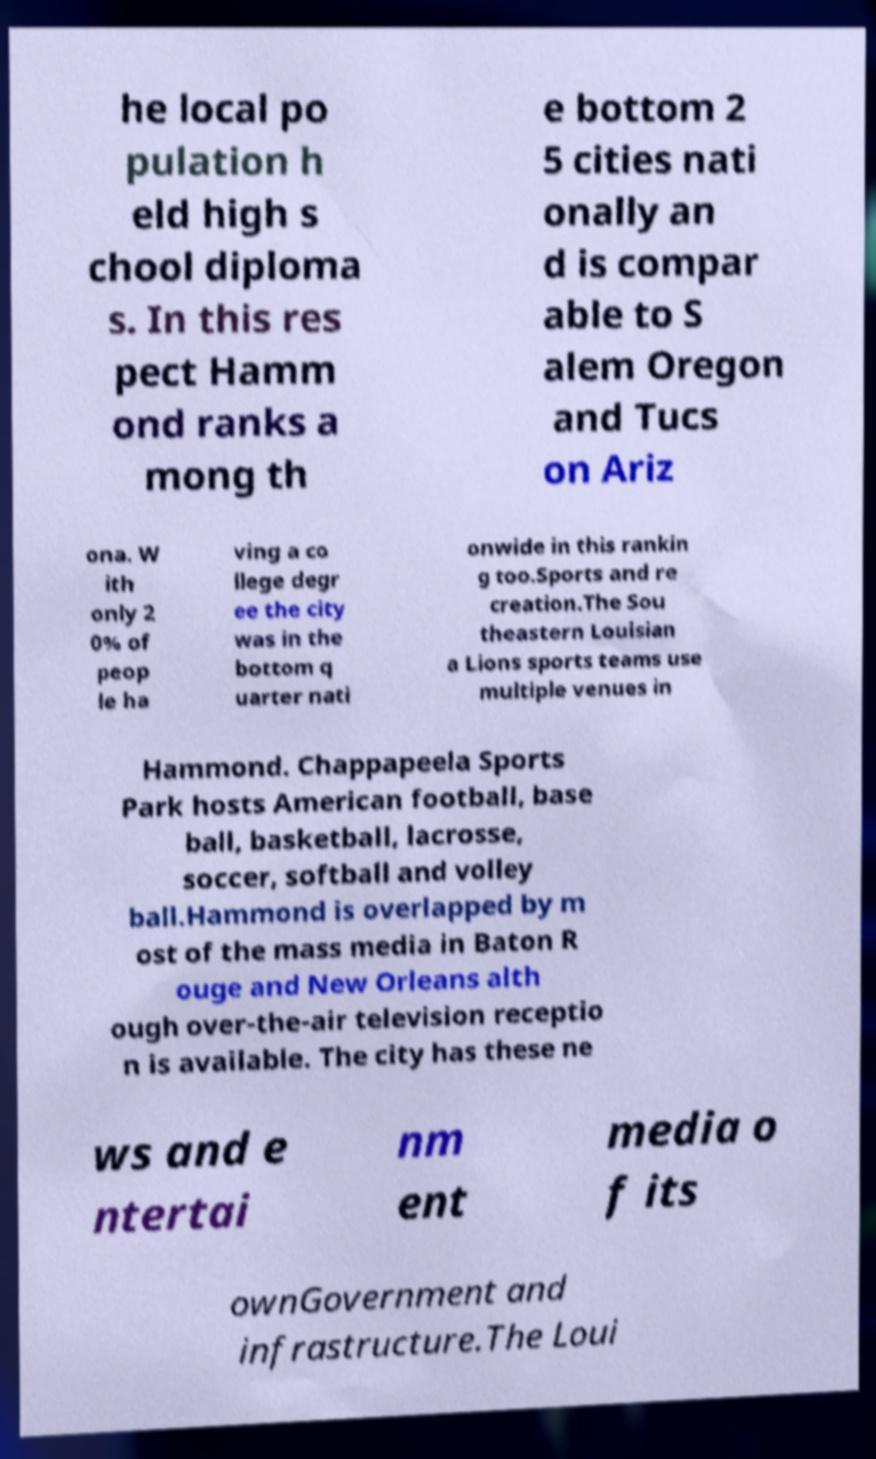Please identify and transcribe the text found in this image. he local po pulation h eld high s chool diploma s. In this res pect Hamm ond ranks a mong th e bottom 2 5 cities nati onally an d is compar able to S alem Oregon and Tucs on Ariz ona. W ith only 2 0% of peop le ha ving a co llege degr ee the city was in the bottom q uarter nati onwide in this rankin g too.Sports and re creation.The Sou theastern Louisian a Lions sports teams use multiple venues in Hammond. Chappapeela Sports Park hosts American football, base ball, basketball, lacrosse, soccer, softball and volley ball.Hammond is overlapped by m ost of the mass media in Baton R ouge and New Orleans alth ough over-the-air television receptio n is available. The city has these ne ws and e ntertai nm ent media o f its ownGovernment and infrastructure.The Loui 